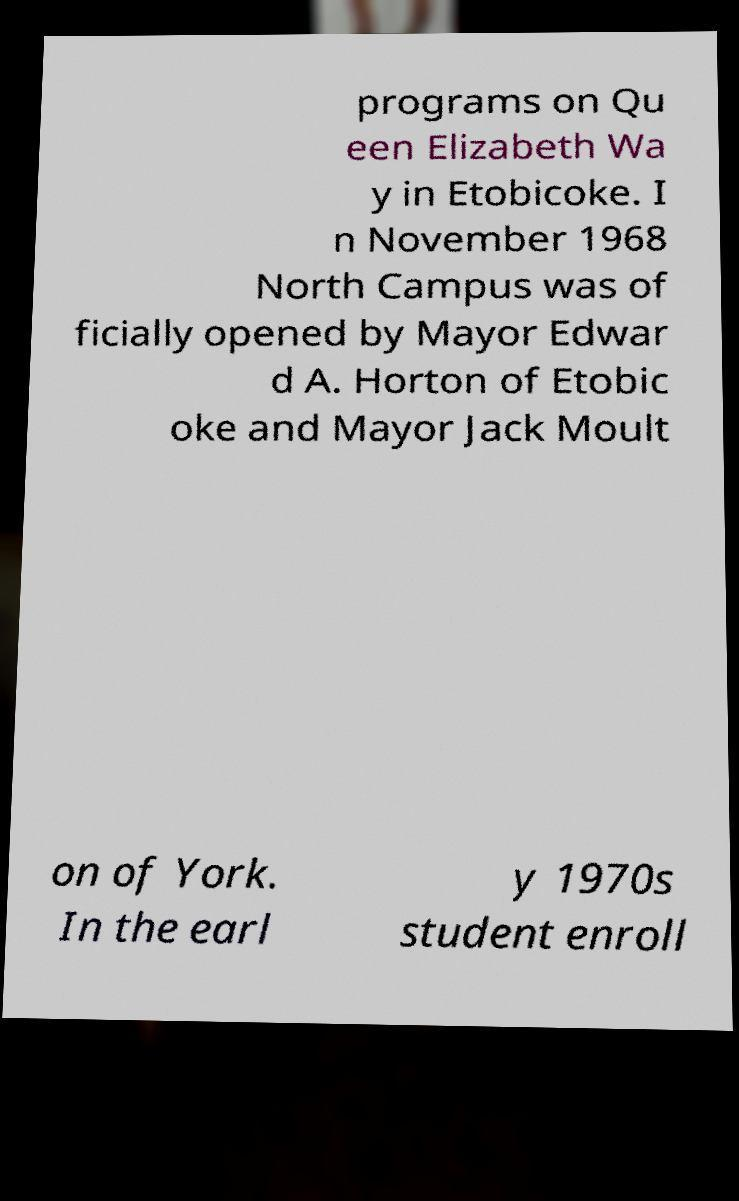There's text embedded in this image that I need extracted. Can you transcribe it verbatim? programs on Qu een Elizabeth Wa y in Etobicoke. I n November 1968 North Campus was of ficially opened by Mayor Edwar d A. Horton of Etobic oke and Mayor Jack Moult on of York. In the earl y 1970s student enroll 